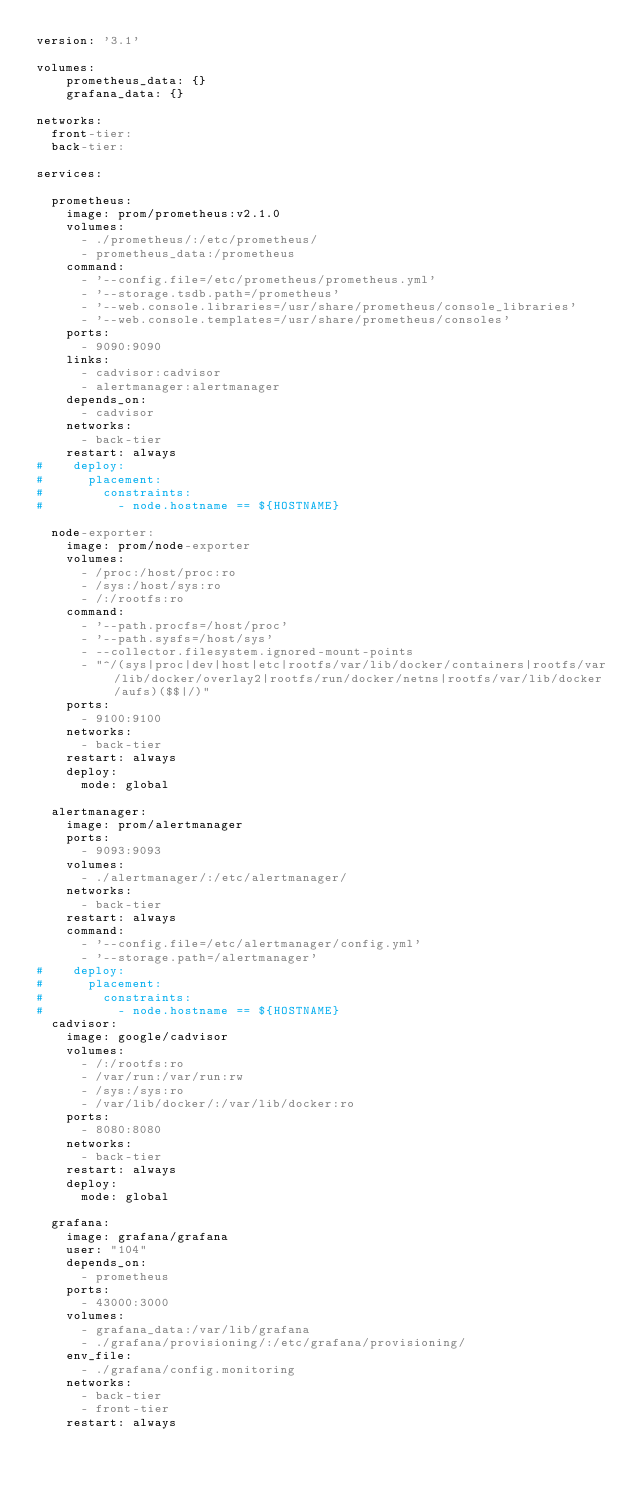<code> <loc_0><loc_0><loc_500><loc_500><_YAML_>version: '3.1'

volumes:
    prometheus_data: {}
    grafana_data: {}

networks:
  front-tier:
  back-tier:

services:

  prometheus:
    image: prom/prometheus:v2.1.0
    volumes:
      - ./prometheus/:/etc/prometheus/
      - prometheus_data:/prometheus
    command:
      - '--config.file=/etc/prometheus/prometheus.yml'
      - '--storage.tsdb.path=/prometheus'
      - '--web.console.libraries=/usr/share/prometheus/console_libraries'
      - '--web.console.templates=/usr/share/prometheus/consoles'
    ports:
      - 9090:9090
    links:
      - cadvisor:cadvisor
      - alertmanager:alertmanager
    depends_on:
      - cadvisor
    networks:
      - back-tier
    restart: always
#    deploy:
#      placement:
#        constraints:
#          - node.hostname == ${HOSTNAME}

  node-exporter:
    image: prom/node-exporter
    volumes:
      - /proc:/host/proc:ro
      - /sys:/host/sys:ro
      - /:/rootfs:ro
    command: 
      - '--path.procfs=/host/proc' 
      - '--path.sysfs=/host/sys'
      - --collector.filesystem.ignored-mount-points
      - "^/(sys|proc|dev|host|etc|rootfs/var/lib/docker/containers|rootfs/var/lib/docker/overlay2|rootfs/run/docker/netns|rootfs/var/lib/docker/aufs)($$|/)"
    ports:
      - 9100:9100
    networks:
      - back-tier
    restart: always
    deploy:
      mode: global

  alertmanager:
    image: prom/alertmanager
    ports:
      - 9093:9093
    volumes:
      - ./alertmanager/:/etc/alertmanager/
    networks:
      - back-tier
    restart: always
    command:
      - '--config.file=/etc/alertmanager/config.yml'
      - '--storage.path=/alertmanager'
#    deploy:
#      placement:
#        constraints:
#          - node.hostname == ${HOSTNAME}
  cadvisor:
    image: google/cadvisor
    volumes:
      - /:/rootfs:ro
      - /var/run:/var/run:rw
      - /sys:/sys:ro
      - /var/lib/docker/:/var/lib/docker:ro
    ports:
      - 8080:8080
    networks:
      - back-tier
    restart: always
    deploy:
      mode: global

  grafana:
    image: grafana/grafana
    user: "104"
    depends_on:
      - prometheus
    ports:
      - 43000:3000
    volumes:
      - grafana_data:/var/lib/grafana
      - ./grafana/provisioning/:/etc/grafana/provisioning/
    env_file:
      - ./grafana/config.monitoring
    networks:
      - back-tier
      - front-tier
    restart: always

</code> 